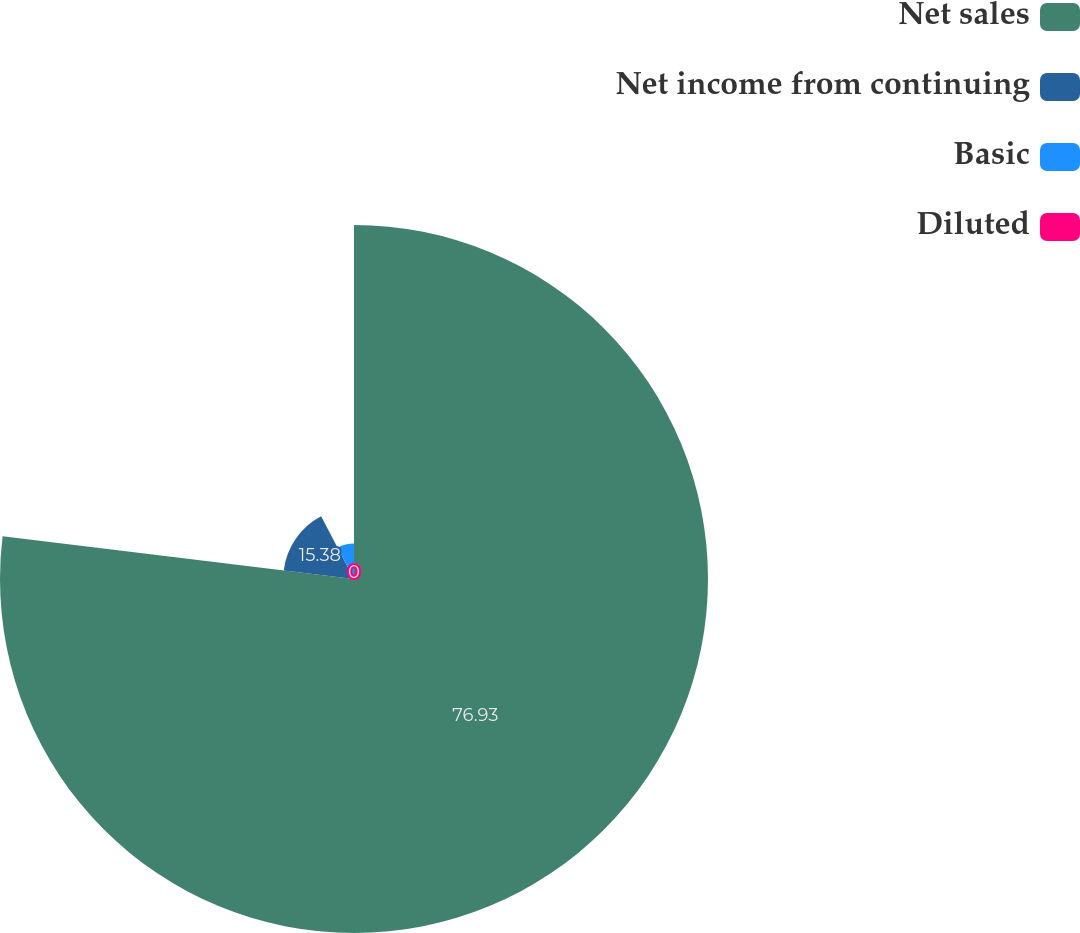<chart> <loc_0><loc_0><loc_500><loc_500><pie_chart><fcel>Net sales<fcel>Net income from continuing<fcel>Basic<fcel>Diluted<nl><fcel>76.92%<fcel>15.38%<fcel>7.69%<fcel>0.0%<nl></chart> 